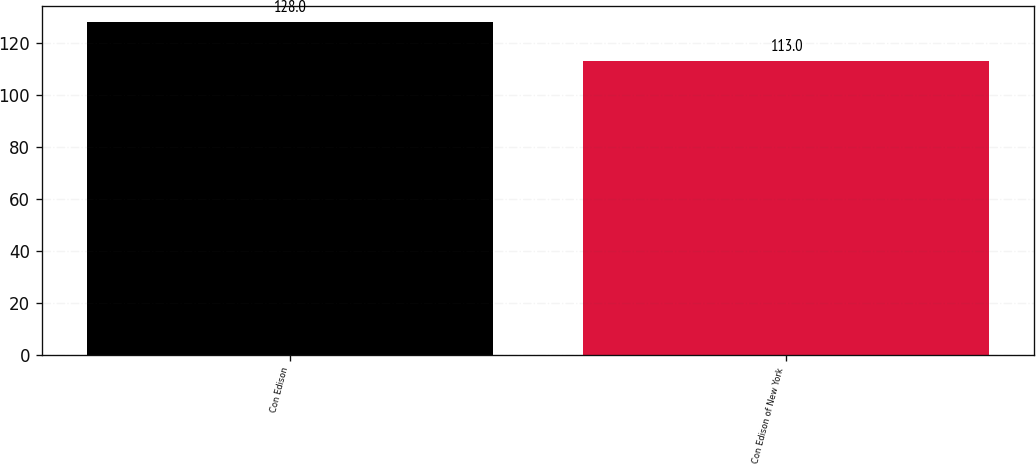Convert chart to OTSL. <chart><loc_0><loc_0><loc_500><loc_500><bar_chart><fcel>Con Edison<fcel>Con Edison of New York<nl><fcel>128<fcel>113<nl></chart> 